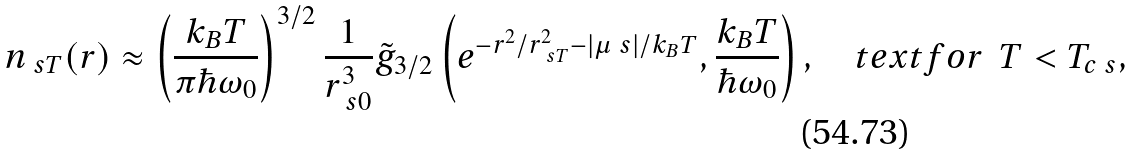<formula> <loc_0><loc_0><loc_500><loc_500>n _ { \ s T } ( r ) \approx \left ( \frac { k _ { B } T } { \pi \hbar { \omega } _ { 0 } } \right ) ^ { 3 / 2 } \frac { 1 } { r _ { \ s 0 } ^ { 3 } } \tilde { g } _ { 3 / 2 } \left ( e ^ { - r ^ { 2 } / r _ { \ s T } ^ { 2 } - | \mu _ { \ } s | / k _ { B } T } , \frac { k _ { B } T } { \hbar { \omega } _ { 0 } } \right ) , \quad t e x t { f o r } \ \ T < T _ { c \ s } ,</formula> 